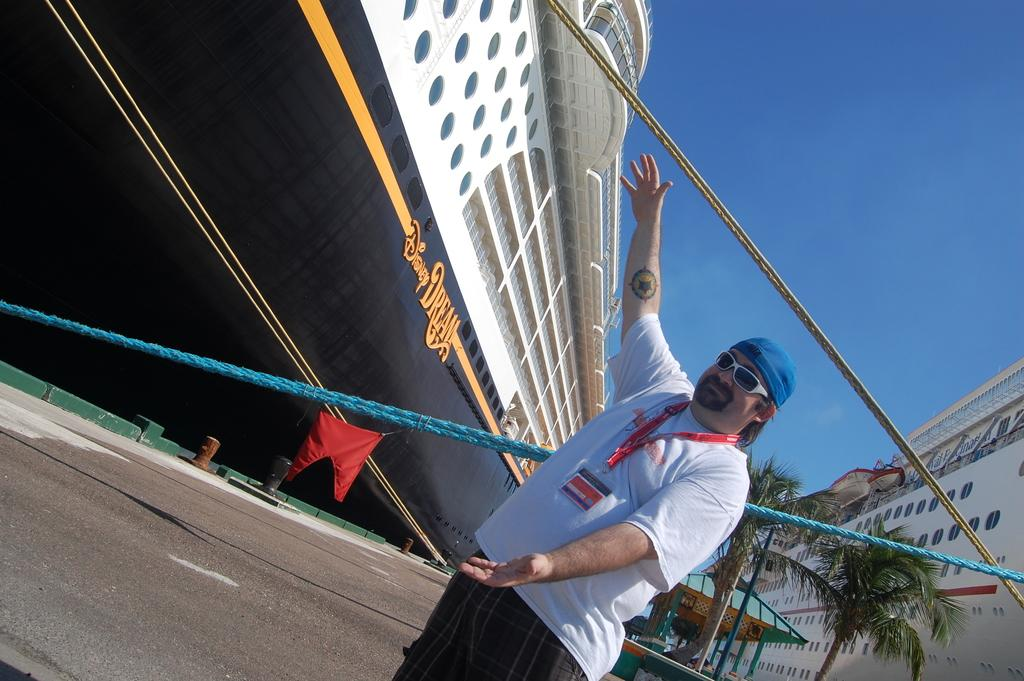What can be seen in the image related to transportation? There are two ships in the image. Are there any people visible in the image? Yes, there are persons visible in the image. What type of vegetation can be seen in the image? There are trees in the image. What other objects can be seen in the image? There are threads and tents visible in the image. What is visible in the top right corner of the image? The sky is visible in the top right corner of the image. What type of insect can be seen crawling on the tents in the image? There are no insects visible in the image; only the ships, persons, trees, threads, tents, and sky are present. What country is the image taken in? The provided facts do not mention the country where the image was taken. 